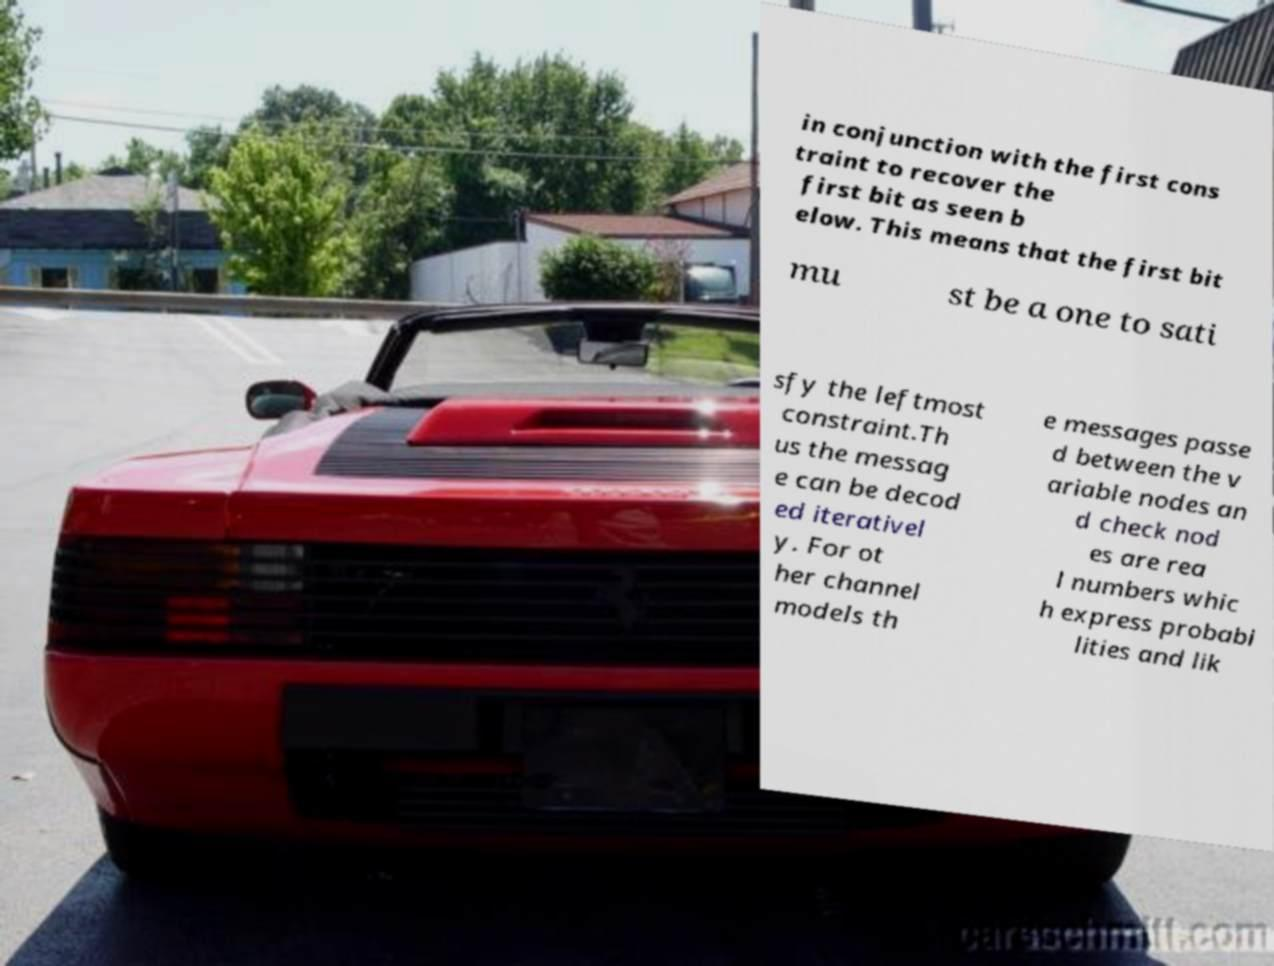Please read and relay the text visible in this image. What does it say? in conjunction with the first cons traint to recover the first bit as seen b elow. This means that the first bit mu st be a one to sati sfy the leftmost constraint.Th us the messag e can be decod ed iterativel y. For ot her channel models th e messages passe d between the v ariable nodes an d check nod es are rea l numbers whic h express probabi lities and lik 